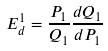Convert formula to latex. <formula><loc_0><loc_0><loc_500><loc_500>E ^ { 1 } _ { d } = \frac { P _ { 1 } } { Q _ { 1 } } \frac { d Q _ { 1 } } { d P _ { 1 } }</formula> 